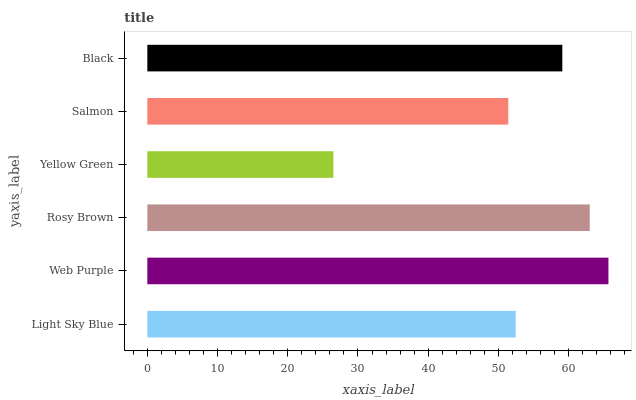Is Yellow Green the minimum?
Answer yes or no. Yes. Is Web Purple the maximum?
Answer yes or no. Yes. Is Rosy Brown the minimum?
Answer yes or no. No. Is Rosy Brown the maximum?
Answer yes or no. No. Is Web Purple greater than Rosy Brown?
Answer yes or no. Yes. Is Rosy Brown less than Web Purple?
Answer yes or no. Yes. Is Rosy Brown greater than Web Purple?
Answer yes or no. No. Is Web Purple less than Rosy Brown?
Answer yes or no. No. Is Black the high median?
Answer yes or no. Yes. Is Light Sky Blue the low median?
Answer yes or no. Yes. Is Yellow Green the high median?
Answer yes or no. No. Is Rosy Brown the low median?
Answer yes or no. No. 